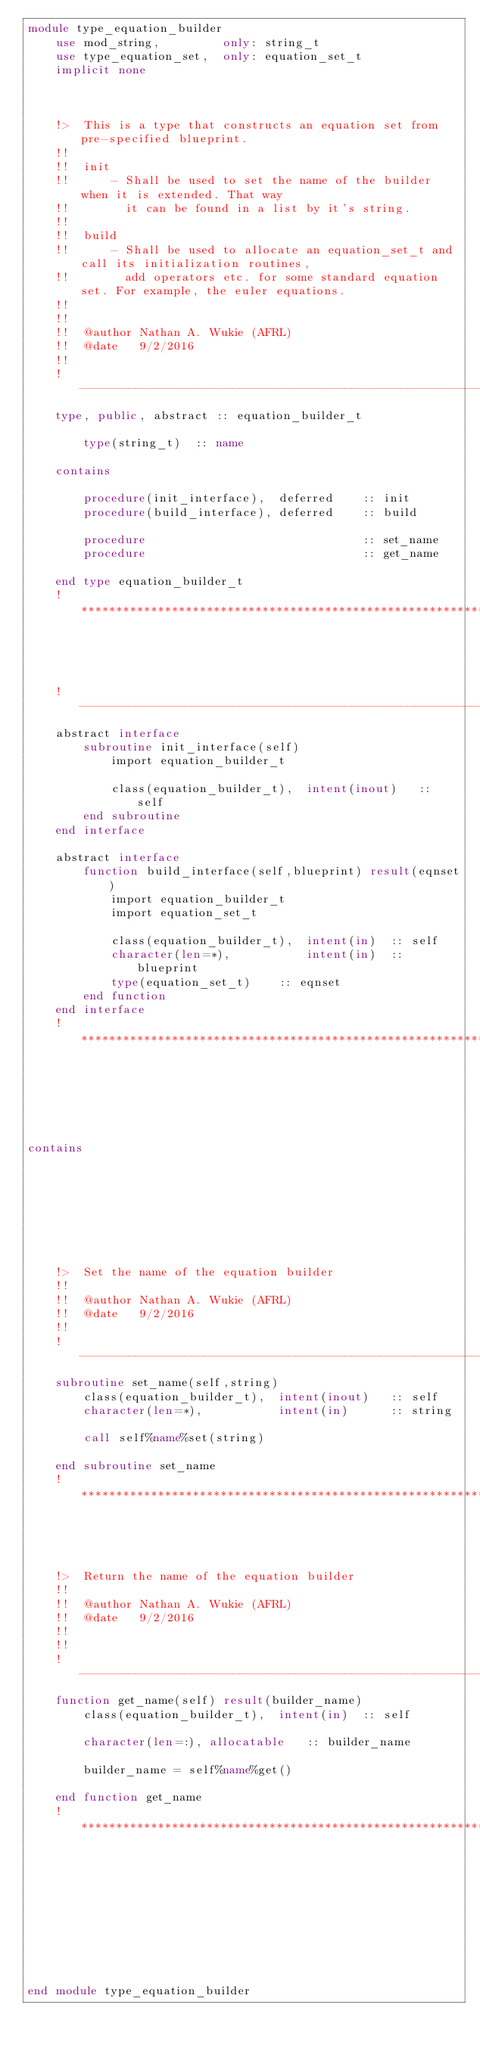<code> <loc_0><loc_0><loc_500><loc_500><_FORTRAN_>module type_equation_builder
    use mod_string,         only: string_t
    use type_equation_set,  only: equation_set_t
    implicit none



    !>  This is a type that constructs an equation set from pre-specified blueprint.
    !!
    !!  init
    !!      - Shall be used to set the name of the builder when it is extended. That way 
    !!        it can be found in a list by it's string.
    !!
    !!  build
    !!      - Shall be used to allocate an equation_set_t and call its initialization routines,
    !!        add operators etc. for some standard equation set. For example, the euler equations.
    !!        
    !!
    !!  @author Nathan A. Wukie (AFRL)
    !!  @date   9/2/2016
    !!
    !---------------------------------------------------------------------------------------------
    type, public, abstract :: equation_builder_t

        type(string_t)  :: name

    contains

        procedure(init_interface),  deferred    :: init
        procedure(build_interface), deferred    :: build

        procedure                               :: set_name
        procedure                               :: get_name

    end type equation_builder_t
    !*********************************************************************************************




    !---------------------------------------------------------------------------------------------
    abstract interface
        subroutine init_interface(self)
            import equation_builder_t

            class(equation_builder_t),  intent(inout)   :: self
        end subroutine
    end interface

    abstract interface
        function build_interface(self,blueprint) result(eqnset)
            import equation_builder_t
            import equation_set_t

            class(equation_builder_t),  intent(in)  :: self
            character(len=*),           intent(in)  :: blueprint
            type(equation_set_t)    :: eqnset
        end function
    end interface
    !*********************************************************************************************






contains








    !>  Set the name of the equation builder
    !!
    !!  @author Nathan A. Wukie (AFRL)
    !!  @date   9/2/2016
    !!
    !---------------------------------------------------------------------------------------------
    subroutine set_name(self,string)
        class(equation_builder_t),  intent(inout)   :: self
        character(len=*),           intent(in)      :: string

        call self%name%set(string)

    end subroutine set_name
    !*********************************************************************************************
    

    

    !>  Return the name of the equation builder
    !!
    !!  @author Nathan A. Wukie (AFRL)
    !!  @date   9/2/2016
    !!
    !!
    !---------------------------------------------------------------------------------------------
    function get_name(self) result(builder_name)
        class(equation_builder_t),  intent(in)  :: self

        character(len=:), allocatable   :: builder_name

        builder_name = self%name%get()

    end function get_name
    !*********************************************************************************************










end module type_equation_builder
</code> 